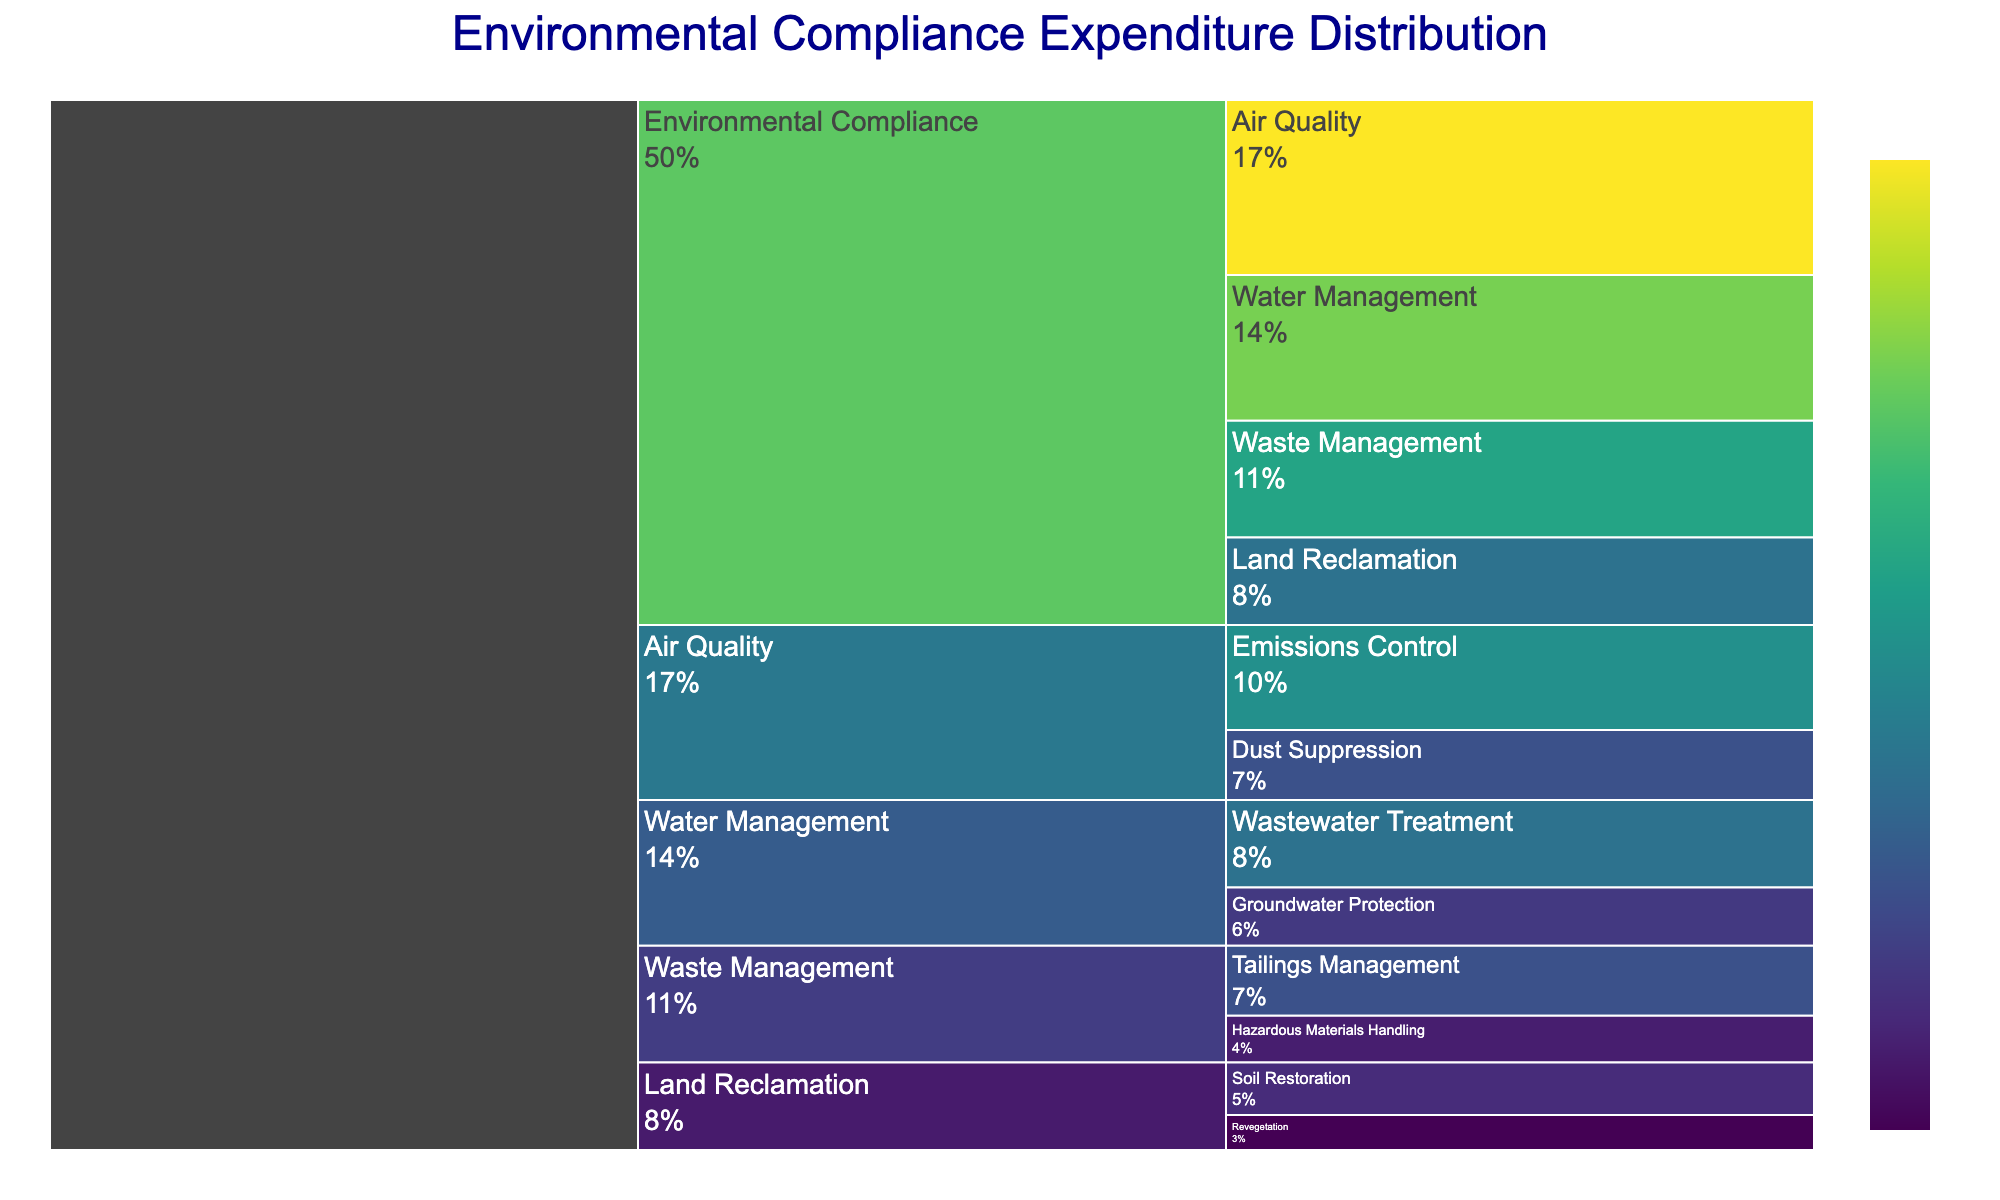What's the title of the chart? The title of the chart can be found at the top of the figure. By looking at that area, we can read the title displayed in large, bold text.
Answer: Environmental Compliance Expenditure Distribution Which regulatory category has the highest expenditure? To answer this, observe the largest segment within the first level of the icicle chart, which usually indicates the category with the highest value.
Answer: Air Quality How much is spent on Emissions Control? Locate Emissions Control in the chart, and observe the corresponding value labeled on or near this segment.
Answer: 18 What is the combined expenditure on Waste Management and Land Reclamation? First, find the values for Waste Management (20) and Land Reclamation (15) in the chart and then calculate their sum: 20 + 15 = 35.
Answer: 35 Which subcategory under Water Management has a higher expenditure? Compare the segments labeled as Wastewater Treatment and Groundwater Protection under the Water Management category. Wastewater Treatment has a larger segment.
Answer: Wastewater Treatment What's the percentage expenditure on Air Quality relative to Environmental Compliance? The percentage can be calculated by taking the Air Quality value (30), dividing it by the total Environmental Compliance value (sum of all categories: 30 + 25 + 20 + 15), and then multiplying by 100. (30 / 90) * 100 = 33.3%
Answer: 33.3% Which subcategory has the smallest expenditure, and how much is it? Identify the smallest segment among all subcategories in the icicle chart and read its labeled value.
Answer: Revegetation - 6 How does expenditure on Dust Suppression compare to Soil Restoration? Locate the values for Dust Suppression (12) and Soil Restoration (9) in the chart and note that Dust Suppression is greater than Soil Restoration.
Answer: Dust Suppression is higher What is the total expenditure on subcategories related to Water Management? Sum the values of each subcategory under Water Management: Wastewater Treatment (15) and Groundwater Protection (10). The total is 15 + 10 = 25.
Answer: 25 What percentage of the total expenditure does Land Reclamation represent? Calculate the total Land Reclamation expenditure (15) as a percentage of the overall total (sum: 90). The formula is (15 / 90) * 100 = 16.7%.
Answer: 16.7% 